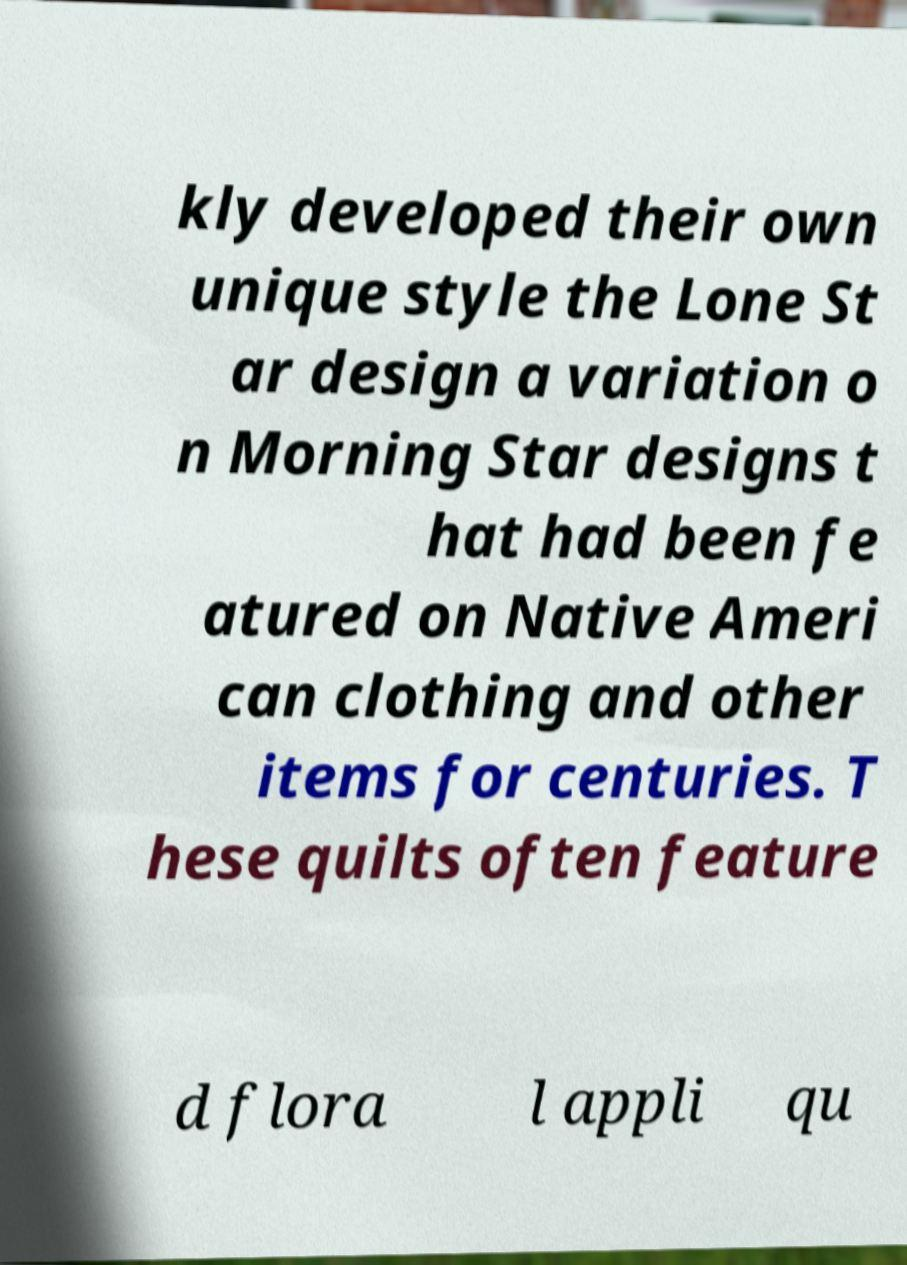For documentation purposes, I need the text within this image transcribed. Could you provide that? kly developed their own unique style the Lone St ar design a variation o n Morning Star designs t hat had been fe atured on Native Ameri can clothing and other items for centuries. T hese quilts often feature d flora l appli qu 